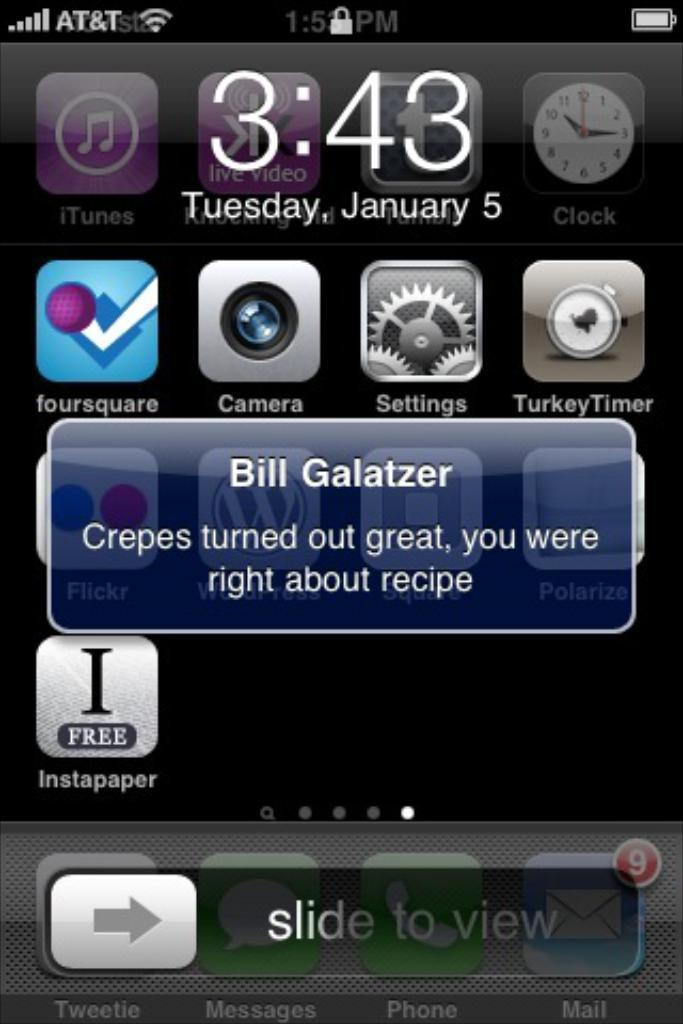What type of device is shown in the image? The image is a screenshot of an iPhone. What can be seen on the iPhone screen? There are icons, the time and date, the battery symbol, and a message visible on the iPhone screen. Can you describe the message on the iPhone screen? Unfortunately, the content of the message cannot be determined from the image. How can the battery status be determined from the image? The battery symbol on the iPhone screen indicates the battery status. What type of straw is used to stir the popcorn in the image? There is no popcorn or straw present in the image; it is a screenshot of an iPhone. How is the yoke attached to the device in the image? There is no yoke or attachment visible in the image, as it is a screenshot of an iPhone. 